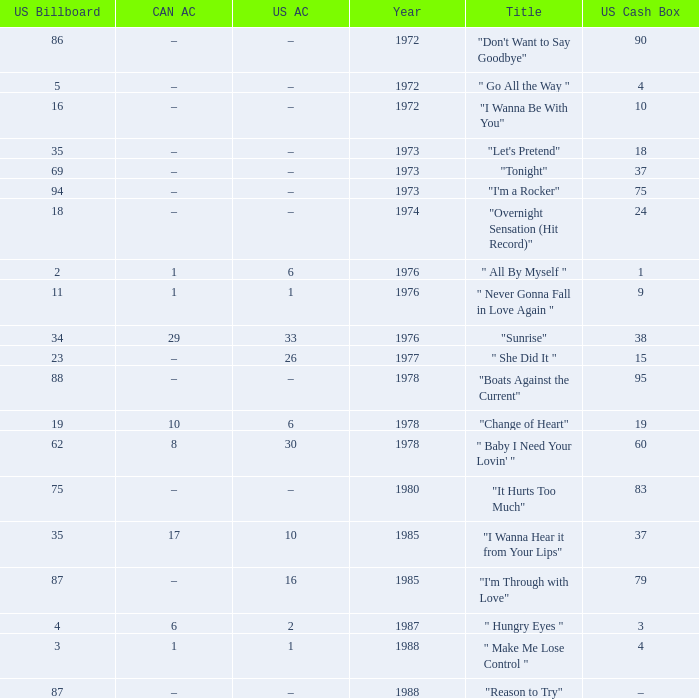What is the US cash box before 1978 with a US billboard of 35? 18.0. 